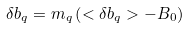Convert formula to latex. <formula><loc_0><loc_0><loc_500><loc_500>\delta b _ { q } = m _ { q } \left ( < \delta b _ { q } > - B _ { 0 } \right )</formula> 